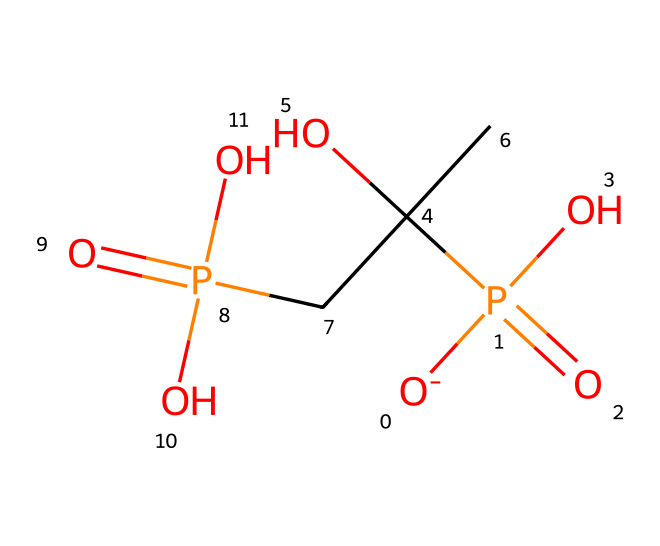What is the primary functional group present in fosfomycin? The structure contains a phosphorus atom bonded to four oxygen atoms (with one being a negatively charged oxygen), characteristic of phosphonate functional groups.
Answer: phosphonate How many oxygen atoms are in the fosfomycin structure? By counting the oxygen atoms in the SMILES representation, there are a total of five oxygen atoms present, indicated by the occurrences of 'O' in the structure.
Answer: five How many carbon atoms are present in fosfomycin? Analyzing the SMILES representation shows that there are three carbon atoms, identified by the instances of 'C' in the structure.
Answer: three What is the molecular weight of fosfomycin approximately? Calculating the molecular weight from the number of each type of atom (C, H, O, P) yields an approximate weight of 138 grams per mole for fosfomycin.
Answer: 138 Is fosfomycin an antibiotic? Fosfomycin is classified as an antibiotic, specifically targeting bacterial infections and is used in treating multidrug-resistant strains.
Answer: yes What type of bond connects phosphorus to oxygen in fosfomycin? The phosphorus atom is connected to oxygen via covalent bonds, which are strong bonds formed by the sharing of electrons between the atoms.
Answer: covalent Does fosfomycin contain any nitrogen atoms? The SMILES representation does not include any 'N' notations, indicating there are no nitrogen atoms present in the structure.
Answer: no 